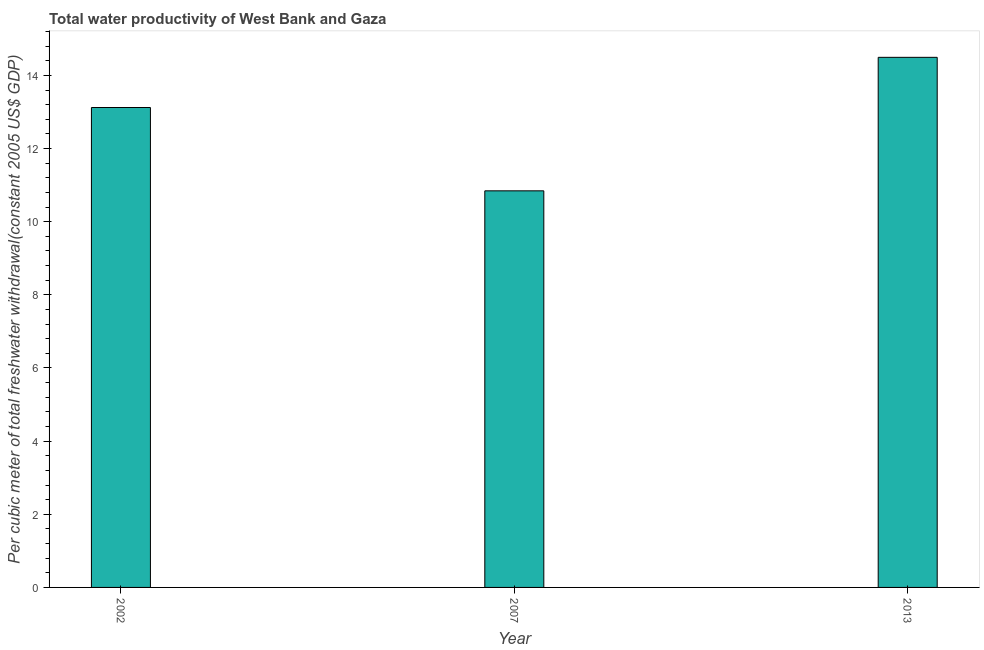Does the graph contain any zero values?
Provide a succinct answer. No. What is the title of the graph?
Ensure brevity in your answer.  Total water productivity of West Bank and Gaza. What is the label or title of the X-axis?
Give a very brief answer. Year. What is the label or title of the Y-axis?
Your response must be concise. Per cubic meter of total freshwater withdrawal(constant 2005 US$ GDP). What is the total water productivity in 2013?
Give a very brief answer. 14.49. Across all years, what is the maximum total water productivity?
Ensure brevity in your answer.  14.49. Across all years, what is the minimum total water productivity?
Your answer should be compact. 10.84. In which year was the total water productivity maximum?
Your answer should be compact. 2013. In which year was the total water productivity minimum?
Ensure brevity in your answer.  2007. What is the sum of the total water productivity?
Ensure brevity in your answer.  38.46. What is the difference between the total water productivity in 2002 and 2007?
Ensure brevity in your answer.  2.28. What is the average total water productivity per year?
Give a very brief answer. 12.82. What is the median total water productivity?
Make the answer very short. 13.12. Do a majority of the years between 2002 and 2013 (inclusive) have total water productivity greater than 13.6 US$?
Your answer should be very brief. No. What is the ratio of the total water productivity in 2002 to that in 2013?
Offer a terse response. 0.91. What is the difference between the highest and the second highest total water productivity?
Offer a terse response. 1.37. What is the difference between the highest and the lowest total water productivity?
Your answer should be very brief. 3.65. In how many years, is the total water productivity greater than the average total water productivity taken over all years?
Offer a terse response. 2. How many bars are there?
Your answer should be compact. 3. Are the values on the major ticks of Y-axis written in scientific E-notation?
Your response must be concise. No. What is the Per cubic meter of total freshwater withdrawal(constant 2005 US$ GDP) in 2002?
Keep it short and to the point. 13.12. What is the Per cubic meter of total freshwater withdrawal(constant 2005 US$ GDP) of 2007?
Provide a succinct answer. 10.84. What is the Per cubic meter of total freshwater withdrawal(constant 2005 US$ GDP) of 2013?
Offer a very short reply. 14.49. What is the difference between the Per cubic meter of total freshwater withdrawal(constant 2005 US$ GDP) in 2002 and 2007?
Your answer should be very brief. 2.28. What is the difference between the Per cubic meter of total freshwater withdrawal(constant 2005 US$ GDP) in 2002 and 2013?
Make the answer very short. -1.37. What is the difference between the Per cubic meter of total freshwater withdrawal(constant 2005 US$ GDP) in 2007 and 2013?
Provide a short and direct response. -3.65. What is the ratio of the Per cubic meter of total freshwater withdrawal(constant 2005 US$ GDP) in 2002 to that in 2007?
Provide a short and direct response. 1.21. What is the ratio of the Per cubic meter of total freshwater withdrawal(constant 2005 US$ GDP) in 2002 to that in 2013?
Make the answer very short. 0.91. What is the ratio of the Per cubic meter of total freshwater withdrawal(constant 2005 US$ GDP) in 2007 to that in 2013?
Make the answer very short. 0.75. 